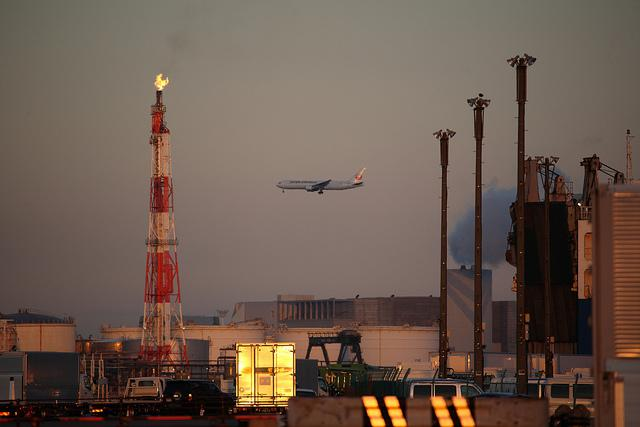What is coming out of the red and white tower? Please explain your reasoning. fire. The fire is coming out. 